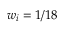Convert formula to latex. <formula><loc_0><loc_0><loc_500><loc_500>w _ { i } = 1 / 1 8</formula> 